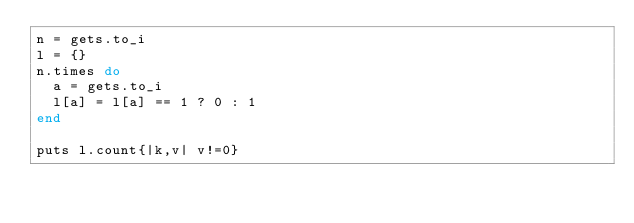Convert code to text. <code><loc_0><loc_0><loc_500><loc_500><_Ruby_>n = gets.to_i
l = {}
n.times do
  a = gets.to_i
  l[a] = l[a] == 1 ? 0 : 1
end

puts l.count{|k,v| v!=0}</code> 